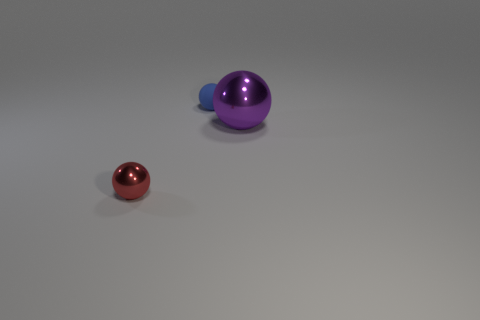Is there anything else that has the same size as the purple metal thing?
Offer a terse response. No. How many red things are the same shape as the small blue rubber thing?
Your answer should be compact. 1. Is the number of objects that are left of the red ball less than the number of red objects on the left side of the purple object?
Ensure brevity in your answer.  Yes. There is a metallic ball that is on the left side of the purple shiny thing; how many balls are on the left side of it?
Ensure brevity in your answer.  0. Is there a green metal object?
Your answer should be very brief. No. Are there any spheres made of the same material as the big thing?
Provide a succinct answer. Yes. Are there more shiny balls on the left side of the big purple ball than tiny red balls that are in front of the blue ball?
Make the answer very short. No. Is the size of the red metallic object the same as the blue sphere?
Your response must be concise. Yes. What color is the metal object behind the tiny thing in front of the tiny blue rubber object?
Keep it short and to the point. Purple. The tiny rubber thing is what color?
Provide a short and direct response. Blue. 